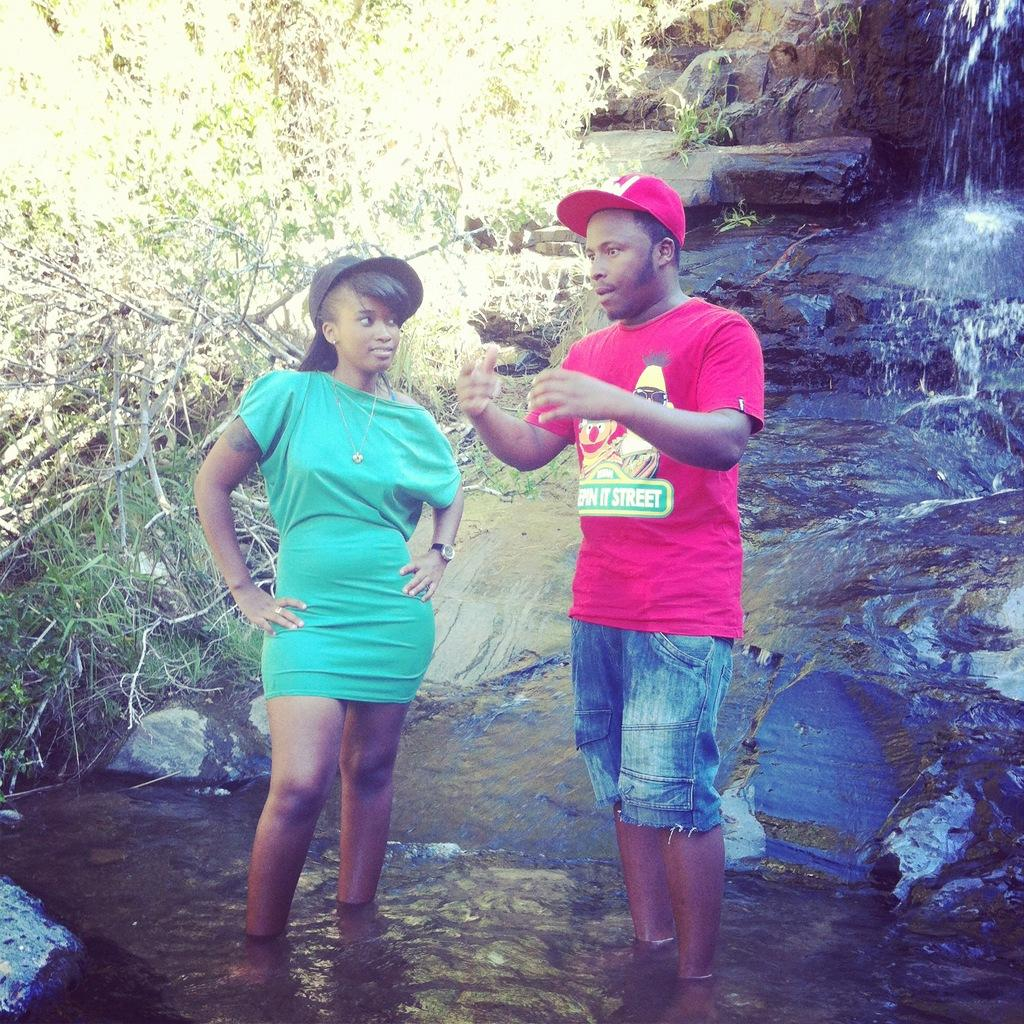How many people are in the image? There are two people in the image, a man and a woman. What are the man and woman doing in the image? Both the man and woman are standing in water. What can be seen in the background of the image? There are trees in the background of the image. What type of bell can be heard ringing in the image? There is no bell present or ringing in the image. What color is the ink used by the police in the image? There are no police or ink present in the image. 